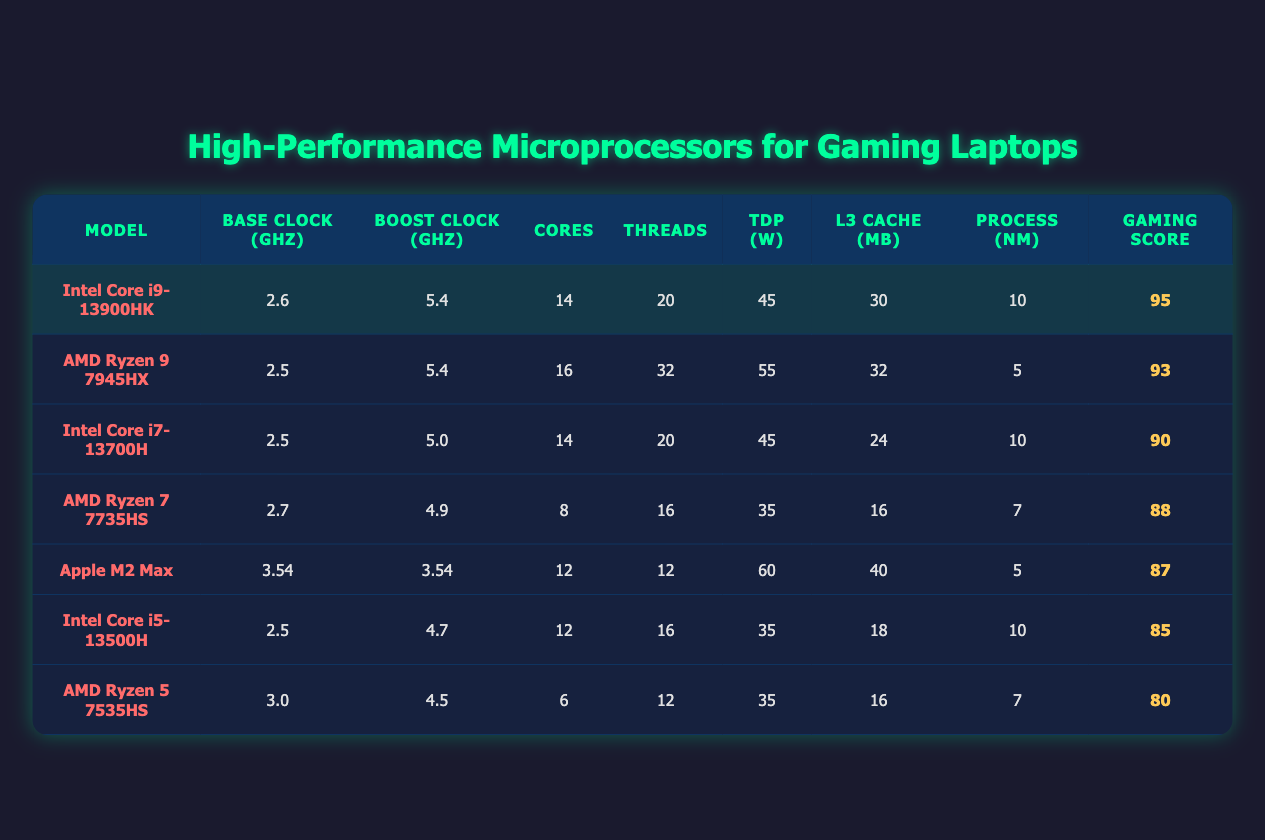What is the Boost Clock Speed of the Intel Core i9-13900HK? The Intel Core i9-13900HK has a Boost Clock Speed of 5.4 GHz as indicated in the "Boost Clock (GHz)" column of the table.
Answer: 5.4 GHz Which microprocessor has the highest number of threads? In the table, the AMD Ryzen 9 7945HX model has the highest number of threads with a total of 32 threads, as shown in the "Threads" column.
Answer: 32 threads What is the average Gaming Performance Score of all listed microprocessors? To find the average, we sum the Gaming Performance Scores: (95 + 93 + 90 + 88 + 87 + 85 + 80) = 718. There are 7 processors, thus the average is 718/7 ≈ 102.57.
Answer: 102.57 Does the Intel Core i5-13500H have more cores than the AMD Ryzen 5 7535HS? The Intel Core i5-13500H has 12 cores, while the AMD Ryzen 5 7535HS has only 6 cores, which means the Intel Core i5-13500H does indeed have more cores.
Answer: Yes What is the difference in Gaming Performance Score between the Intel Core i9-13900HK and the Intel Core i7-13700H? The Gaming Performance Score of the Intel Core i9-13900HK is 95, and the Intel Core i7-13700H is 90. The difference is 95 - 90 = 5.
Answer: 5 Is the Thermal Design Power of the Apple M2 Max greater than that of the AMD Ryzen 5 7535HS? The Apple M2 Max has a Thermal Design Power (TDP) of 60 watts, while the AMD Ryzen 5 7535HS has a TDP of 35 watts. Since 60 is greater than 35, the Apple M2 Max does have a greater TDP.
Answer: Yes Which processor has the lowest Base Clock Speed and what is that speed? By checking the "Base Clock (GHz)" column in the table, the AMD Ryzen 5 7535HS has the lowest Base Clock Speed of 3.0 GHz, making it the lowest among the listed processors.
Answer: 3.0 GHz What is the total number of cores among the three highest scoring processors? The three highest scoring processors are: Intel Core i9-13900HK (14 cores), AMD Ryzen 9 7945HX (16 cores), and Intel Core i7-13700H (14 cores). Adding them together gives us 14 + 16 + 14 = 44 cores.
Answer: 44 cores 